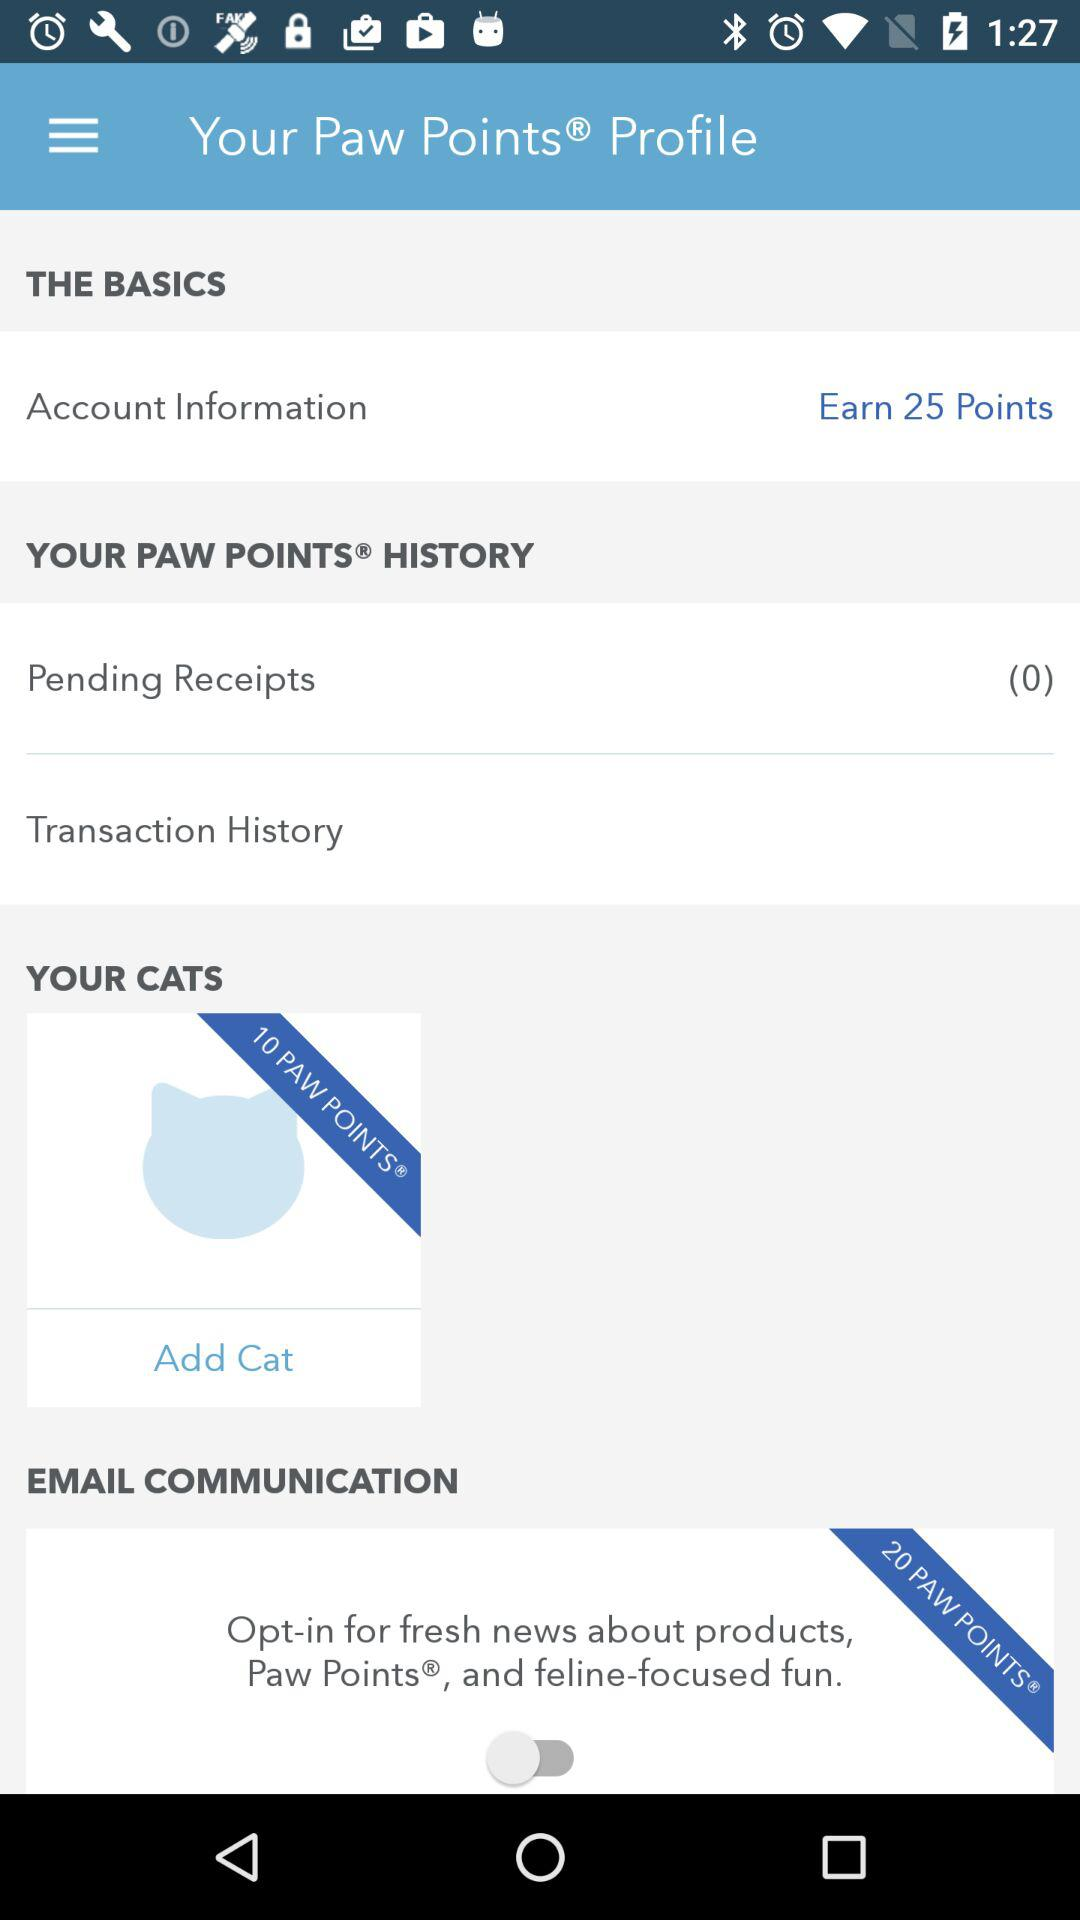How many more paw points can I earn by adding a cat?
Answer the question using a single word or phrase. 10 